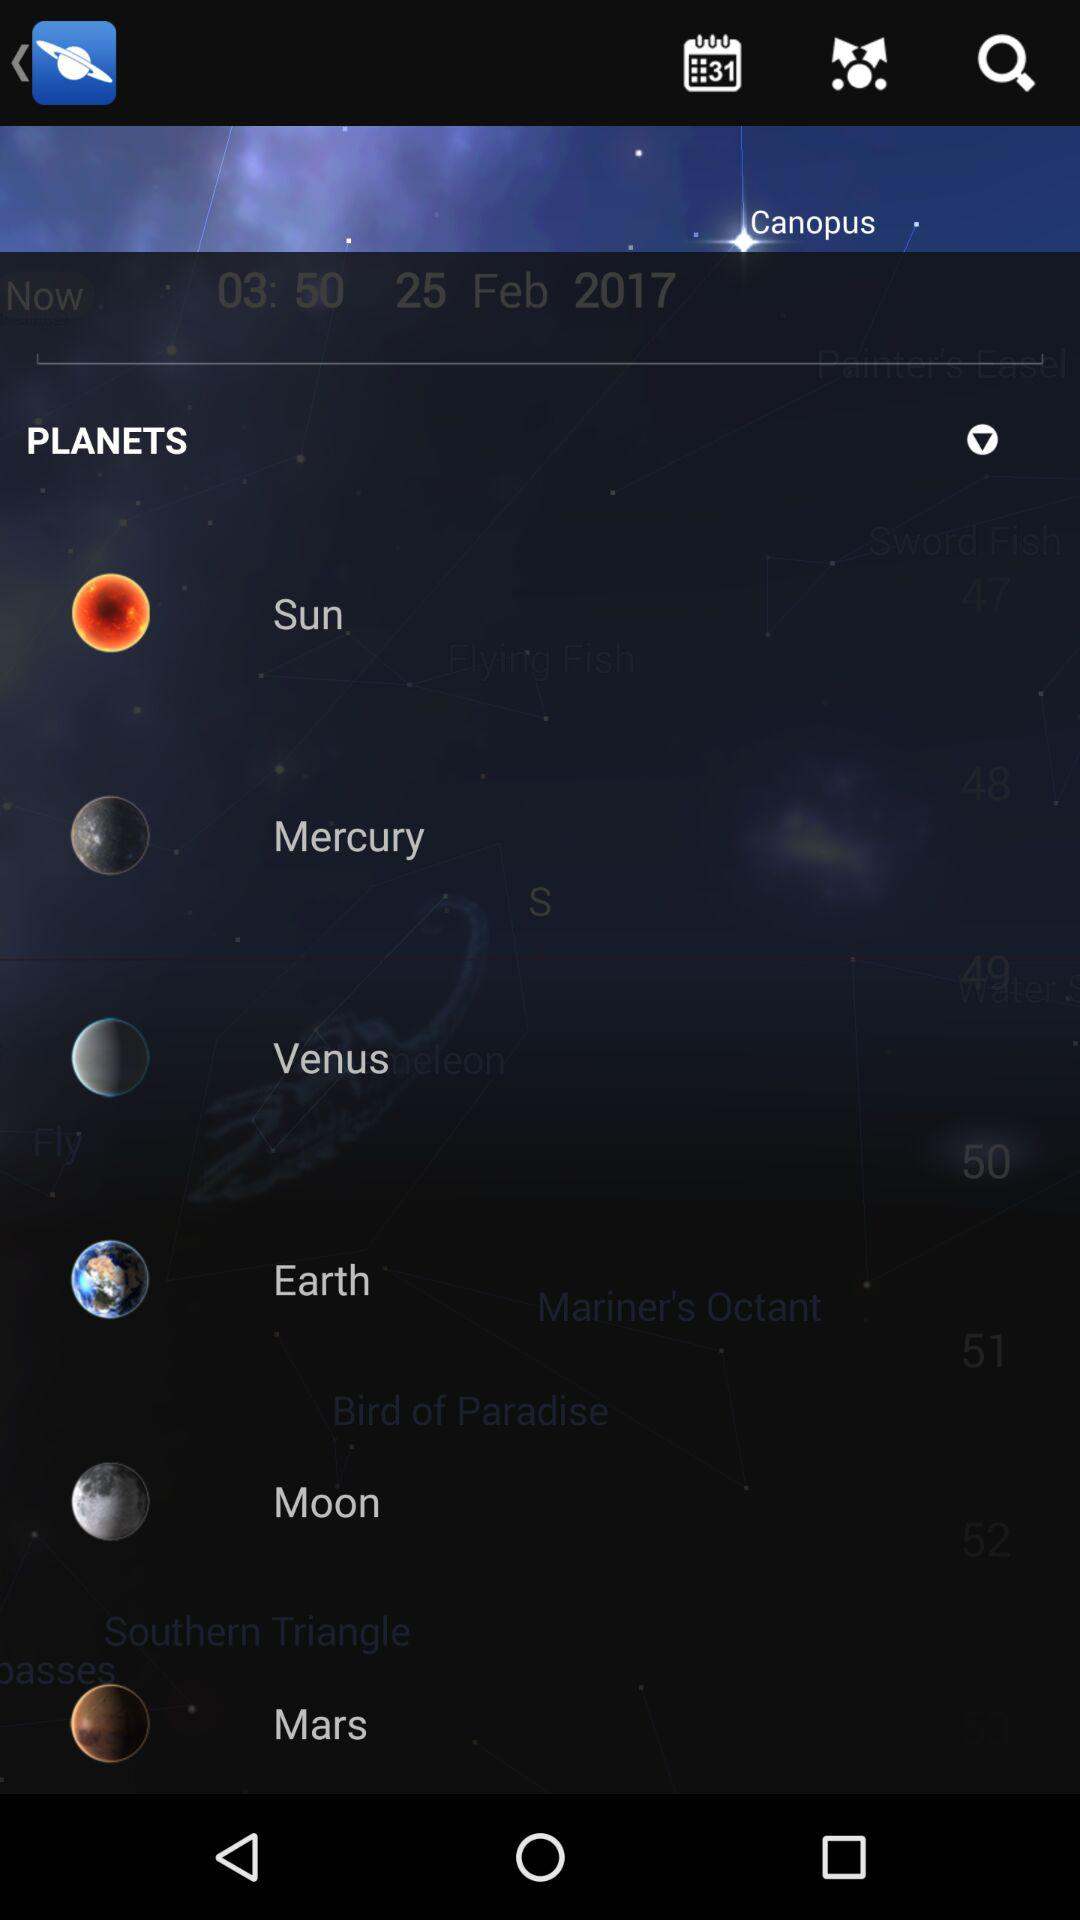What is the date? The date is February 25, 2017. 